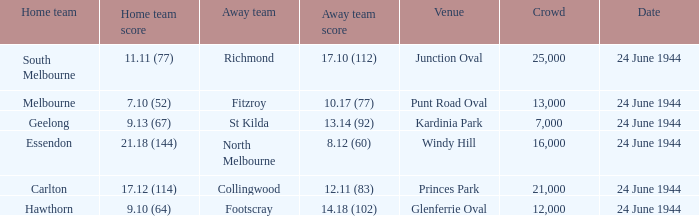When the Crowd was larger than 25,000. what was the Home Team score? None. 